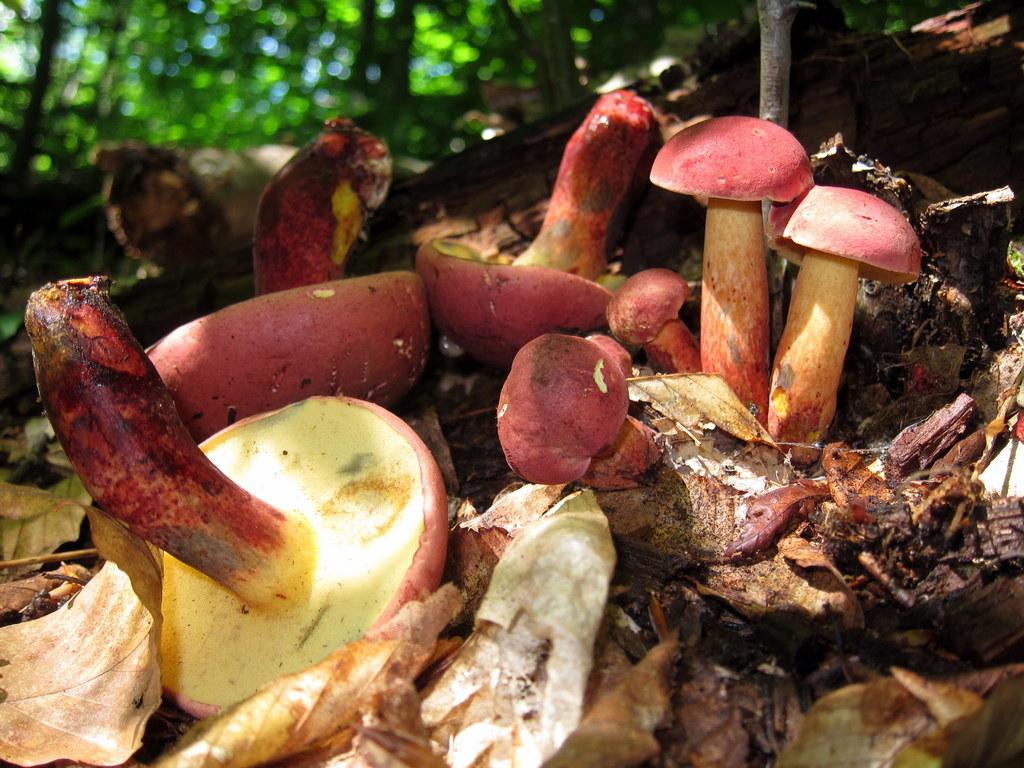What type of fungi can be seen in the image? There are mushrooms in the image. Where are the mushrooms located? The mushrooms are on the land. What else can be found on the land in the image? There are dried leaves on the land. What type of vegetation is visible in the image? There are trees visible in the image. What type of hair can be seen on the donkey in the image? There is no donkey present in the image, and therefore no hair can be observed. What type of pig is visible in the image? There is no pig present in the image. 